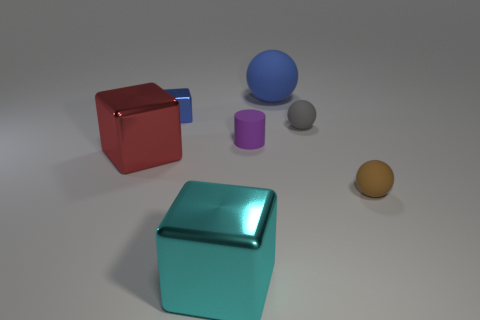Add 1 large rubber spheres. How many objects exist? 8 Subtract all cylinders. How many objects are left? 6 Add 7 purple objects. How many purple objects are left? 8 Add 5 large red rubber spheres. How many large red rubber spheres exist? 5 Subtract 0 blue cylinders. How many objects are left? 7 Subtract all gray matte things. Subtract all big yellow matte cylinders. How many objects are left? 6 